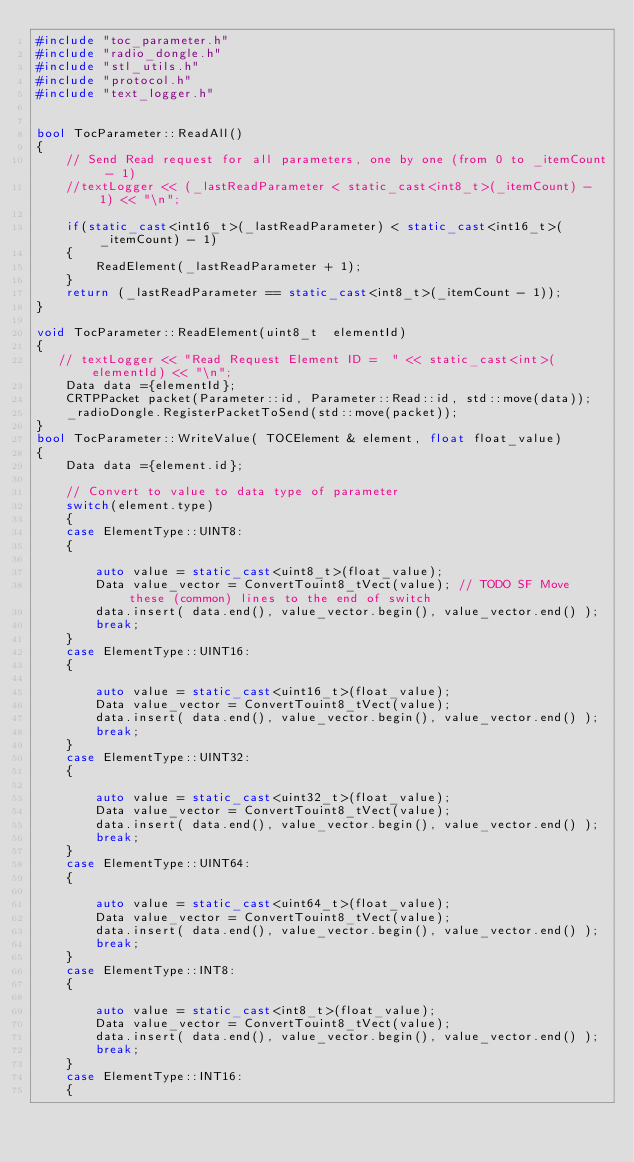Convert code to text. <code><loc_0><loc_0><loc_500><loc_500><_C++_>#include "toc_parameter.h"
#include "radio_dongle.h"
#include "stl_utils.h"
#include "protocol.h"
#include "text_logger.h"


bool TocParameter::ReadAll()
{
    // Send Read request for all parameters, one by one (from 0 to _itemCount - 1)
    //textLogger << (_lastReadParameter < static_cast<int8_t>(_itemCount) - 1) << "\n";

    if(static_cast<int16_t>(_lastReadParameter) < static_cast<int16_t>(_itemCount) - 1)
    {
        ReadElement(_lastReadParameter + 1);
    }
    return (_lastReadParameter == static_cast<int8_t>(_itemCount - 1));
}

void TocParameter::ReadElement(uint8_t  elementId)
{
   // textLogger << "Read Request Element ID =  " << static_cast<int>(elementId) << "\n";
    Data data ={elementId};
    CRTPPacket packet(Parameter::id, Parameter::Read::id, std::move(data));
    _radioDongle.RegisterPacketToSend(std::move(packet));
}
bool TocParameter::WriteValue( TOCElement & element, float float_value)
{
    Data data ={element.id};

    // Convert to value to data type of parameter
    switch(element.type)
    {
    case ElementType::UINT8:
    {

        auto value = static_cast<uint8_t>(float_value);
        Data value_vector = ConvertTouint8_tVect(value); // TODO SF Move these (common) lines to the end of switch
        data.insert( data.end(), value_vector.begin(), value_vector.end() );
        break;
    }
    case ElementType::UINT16:
    {

        auto value = static_cast<uint16_t>(float_value);
        Data value_vector = ConvertTouint8_tVect(value);
        data.insert( data.end(), value_vector.begin(), value_vector.end() );
        break;
    }
    case ElementType::UINT32:
    {

        auto value = static_cast<uint32_t>(float_value);
        Data value_vector = ConvertTouint8_tVect(value);
        data.insert( data.end(), value_vector.begin(), value_vector.end() );
        break;
    }
    case ElementType::UINT64:
    {

        auto value = static_cast<uint64_t>(float_value);
        Data value_vector = ConvertTouint8_tVect(value);
        data.insert( data.end(), value_vector.begin(), value_vector.end() );
        break;
    }
    case ElementType::INT8:
    {

        auto value = static_cast<int8_t>(float_value);
        Data value_vector = ConvertTouint8_tVect(value);
        data.insert( data.end(), value_vector.begin(), value_vector.end() );
        break;
    }
    case ElementType::INT16:
    {
</code> 